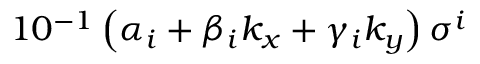Convert formula to latex. <formula><loc_0><loc_0><loc_500><loc_500>1 0 ^ { - 1 } \left ( \alpha _ { i } + \beta _ { i } k _ { x } + \gamma _ { i } k _ { y } \right ) \sigma ^ { i }</formula> 